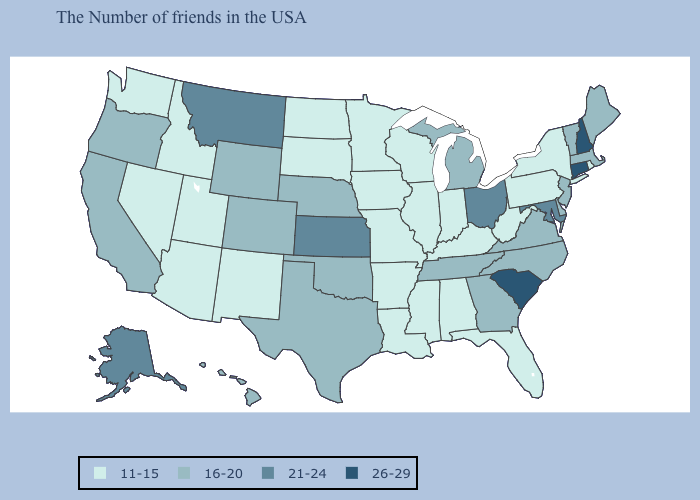Name the states that have a value in the range 21-24?
Give a very brief answer. Maryland, Ohio, Kansas, Montana, Alaska. Does Connecticut have a higher value than New Hampshire?
Short answer required. No. Name the states that have a value in the range 21-24?
Short answer required. Maryland, Ohio, Kansas, Montana, Alaska. How many symbols are there in the legend?
Keep it brief. 4. What is the highest value in the MidWest ?
Answer briefly. 21-24. Does Hawaii have a lower value than Alaska?
Quick response, please. Yes. Which states have the lowest value in the USA?
Short answer required. Rhode Island, New York, Pennsylvania, West Virginia, Florida, Kentucky, Indiana, Alabama, Wisconsin, Illinois, Mississippi, Louisiana, Missouri, Arkansas, Minnesota, Iowa, South Dakota, North Dakota, New Mexico, Utah, Arizona, Idaho, Nevada, Washington. Is the legend a continuous bar?
Write a very short answer. No. Among the states that border Vermont , which have the highest value?
Answer briefly. New Hampshire. What is the value of Indiana?
Short answer required. 11-15. What is the highest value in states that border Montana?
Quick response, please. 16-20. Name the states that have a value in the range 26-29?
Be succinct. New Hampshire, Connecticut, South Carolina. What is the value of Virginia?
Be succinct. 16-20. What is the highest value in the USA?
Be succinct. 26-29. Does the map have missing data?
Write a very short answer. No. 